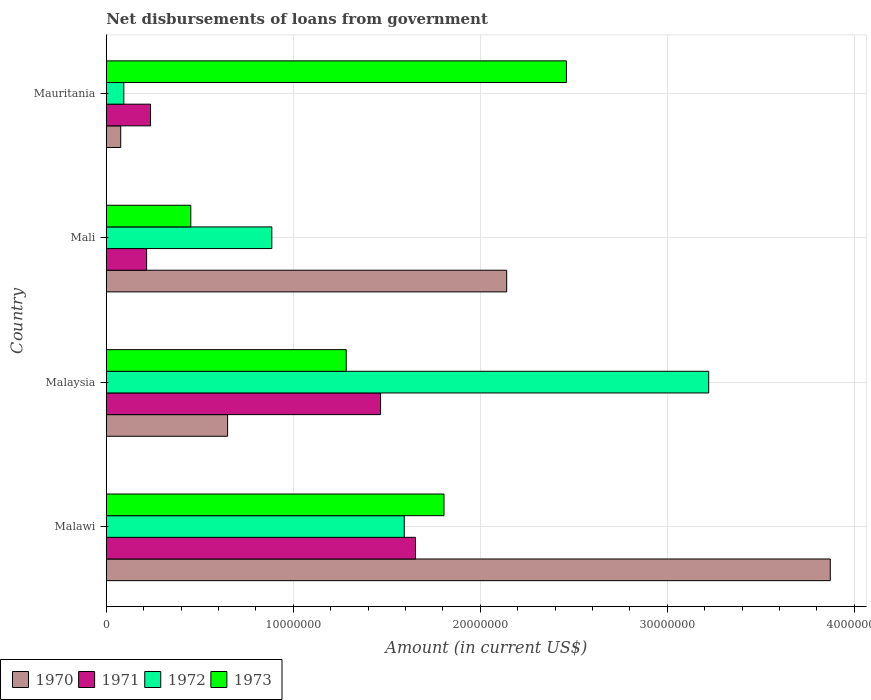How many different coloured bars are there?
Your response must be concise. 4. Are the number of bars per tick equal to the number of legend labels?
Your response must be concise. Yes. How many bars are there on the 4th tick from the top?
Keep it short and to the point. 4. What is the label of the 1st group of bars from the top?
Offer a terse response. Mauritania. What is the amount of loan disbursed from government in 1971 in Mali?
Keep it short and to the point. 2.16e+06. Across all countries, what is the maximum amount of loan disbursed from government in 1972?
Offer a terse response. 3.22e+07. Across all countries, what is the minimum amount of loan disbursed from government in 1972?
Ensure brevity in your answer.  9.39e+05. In which country was the amount of loan disbursed from government in 1971 maximum?
Your answer should be very brief. Malawi. In which country was the amount of loan disbursed from government in 1972 minimum?
Provide a succinct answer. Mauritania. What is the total amount of loan disbursed from government in 1972 in the graph?
Your answer should be compact. 5.79e+07. What is the difference between the amount of loan disbursed from government in 1971 in Malawi and that in Malaysia?
Your response must be concise. 1.87e+06. What is the difference between the amount of loan disbursed from government in 1970 in Malaysia and the amount of loan disbursed from government in 1972 in Mauritania?
Ensure brevity in your answer.  5.55e+06. What is the average amount of loan disbursed from government in 1973 per country?
Ensure brevity in your answer.  1.50e+07. What is the difference between the amount of loan disbursed from government in 1972 and amount of loan disbursed from government in 1971 in Mali?
Your answer should be compact. 6.70e+06. What is the ratio of the amount of loan disbursed from government in 1971 in Malawi to that in Mali?
Make the answer very short. 7.66. What is the difference between the highest and the second highest amount of loan disbursed from government in 1972?
Give a very brief answer. 1.63e+07. What is the difference between the highest and the lowest amount of loan disbursed from government in 1972?
Offer a very short reply. 3.13e+07. Is the sum of the amount of loan disbursed from government in 1973 in Malawi and Mauritania greater than the maximum amount of loan disbursed from government in 1971 across all countries?
Provide a succinct answer. Yes. What does the 2nd bar from the top in Mauritania represents?
Provide a short and direct response. 1972. Are all the bars in the graph horizontal?
Offer a very short reply. Yes. Are the values on the major ticks of X-axis written in scientific E-notation?
Give a very brief answer. No. How are the legend labels stacked?
Give a very brief answer. Horizontal. What is the title of the graph?
Give a very brief answer. Net disbursements of loans from government. Does "2006" appear as one of the legend labels in the graph?
Your answer should be compact. No. What is the label or title of the Y-axis?
Your answer should be compact. Country. What is the Amount (in current US$) in 1970 in Malawi?
Your response must be concise. 3.87e+07. What is the Amount (in current US$) of 1971 in Malawi?
Keep it short and to the point. 1.65e+07. What is the Amount (in current US$) of 1972 in Malawi?
Make the answer very short. 1.59e+07. What is the Amount (in current US$) of 1973 in Malawi?
Your answer should be compact. 1.81e+07. What is the Amount (in current US$) of 1970 in Malaysia?
Make the answer very short. 6.49e+06. What is the Amount (in current US$) of 1971 in Malaysia?
Offer a terse response. 1.47e+07. What is the Amount (in current US$) of 1972 in Malaysia?
Your answer should be compact. 3.22e+07. What is the Amount (in current US$) in 1973 in Malaysia?
Provide a succinct answer. 1.28e+07. What is the Amount (in current US$) of 1970 in Mali?
Your response must be concise. 2.14e+07. What is the Amount (in current US$) of 1971 in Mali?
Your answer should be compact. 2.16e+06. What is the Amount (in current US$) in 1972 in Mali?
Your answer should be very brief. 8.85e+06. What is the Amount (in current US$) of 1973 in Mali?
Your response must be concise. 4.52e+06. What is the Amount (in current US$) of 1970 in Mauritania?
Provide a short and direct response. 7.74e+05. What is the Amount (in current US$) in 1971 in Mauritania?
Provide a short and direct response. 2.37e+06. What is the Amount (in current US$) in 1972 in Mauritania?
Your response must be concise. 9.39e+05. What is the Amount (in current US$) in 1973 in Mauritania?
Provide a succinct answer. 2.46e+07. Across all countries, what is the maximum Amount (in current US$) of 1970?
Offer a very short reply. 3.87e+07. Across all countries, what is the maximum Amount (in current US$) of 1971?
Give a very brief answer. 1.65e+07. Across all countries, what is the maximum Amount (in current US$) in 1972?
Your answer should be compact. 3.22e+07. Across all countries, what is the maximum Amount (in current US$) in 1973?
Make the answer very short. 2.46e+07. Across all countries, what is the minimum Amount (in current US$) in 1970?
Your answer should be compact. 7.74e+05. Across all countries, what is the minimum Amount (in current US$) of 1971?
Offer a terse response. 2.16e+06. Across all countries, what is the minimum Amount (in current US$) of 1972?
Offer a very short reply. 9.39e+05. Across all countries, what is the minimum Amount (in current US$) in 1973?
Offer a terse response. 4.52e+06. What is the total Amount (in current US$) in 1970 in the graph?
Provide a short and direct response. 6.74e+07. What is the total Amount (in current US$) of 1971 in the graph?
Your answer should be very brief. 3.57e+07. What is the total Amount (in current US$) in 1972 in the graph?
Offer a terse response. 5.79e+07. What is the total Amount (in current US$) of 1973 in the graph?
Make the answer very short. 6.00e+07. What is the difference between the Amount (in current US$) of 1970 in Malawi and that in Malaysia?
Your answer should be very brief. 3.22e+07. What is the difference between the Amount (in current US$) in 1971 in Malawi and that in Malaysia?
Offer a terse response. 1.87e+06. What is the difference between the Amount (in current US$) in 1972 in Malawi and that in Malaysia?
Give a very brief answer. -1.63e+07. What is the difference between the Amount (in current US$) in 1973 in Malawi and that in Malaysia?
Offer a terse response. 5.23e+06. What is the difference between the Amount (in current US$) in 1970 in Malawi and that in Mali?
Your answer should be compact. 1.73e+07. What is the difference between the Amount (in current US$) in 1971 in Malawi and that in Mali?
Offer a terse response. 1.44e+07. What is the difference between the Amount (in current US$) in 1972 in Malawi and that in Mali?
Your answer should be compact. 7.08e+06. What is the difference between the Amount (in current US$) in 1973 in Malawi and that in Mali?
Your answer should be very brief. 1.35e+07. What is the difference between the Amount (in current US$) of 1970 in Malawi and that in Mauritania?
Your answer should be compact. 3.79e+07. What is the difference between the Amount (in current US$) of 1971 in Malawi and that in Mauritania?
Offer a terse response. 1.42e+07. What is the difference between the Amount (in current US$) in 1972 in Malawi and that in Mauritania?
Give a very brief answer. 1.50e+07. What is the difference between the Amount (in current US$) of 1973 in Malawi and that in Mauritania?
Your answer should be very brief. -6.55e+06. What is the difference between the Amount (in current US$) of 1970 in Malaysia and that in Mali?
Ensure brevity in your answer.  -1.49e+07. What is the difference between the Amount (in current US$) in 1971 in Malaysia and that in Mali?
Provide a short and direct response. 1.25e+07. What is the difference between the Amount (in current US$) in 1972 in Malaysia and that in Mali?
Your answer should be very brief. 2.34e+07. What is the difference between the Amount (in current US$) in 1973 in Malaysia and that in Mali?
Provide a succinct answer. 8.31e+06. What is the difference between the Amount (in current US$) in 1970 in Malaysia and that in Mauritania?
Your answer should be very brief. 5.72e+06. What is the difference between the Amount (in current US$) in 1971 in Malaysia and that in Mauritania?
Make the answer very short. 1.23e+07. What is the difference between the Amount (in current US$) of 1972 in Malaysia and that in Mauritania?
Provide a short and direct response. 3.13e+07. What is the difference between the Amount (in current US$) in 1973 in Malaysia and that in Mauritania?
Offer a terse response. -1.18e+07. What is the difference between the Amount (in current US$) in 1970 in Mali and that in Mauritania?
Your answer should be very brief. 2.06e+07. What is the difference between the Amount (in current US$) of 1971 in Mali and that in Mauritania?
Your answer should be very brief. -2.09e+05. What is the difference between the Amount (in current US$) in 1972 in Mali and that in Mauritania?
Your answer should be very brief. 7.92e+06. What is the difference between the Amount (in current US$) in 1973 in Mali and that in Mauritania?
Ensure brevity in your answer.  -2.01e+07. What is the difference between the Amount (in current US$) of 1970 in Malawi and the Amount (in current US$) of 1971 in Malaysia?
Your answer should be very brief. 2.40e+07. What is the difference between the Amount (in current US$) in 1970 in Malawi and the Amount (in current US$) in 1972 in Malaysia?
Your answer should be very brief. 6.50e+06. What is the difference between the Amount (in current US$) in 1970 in Malawi and the Amount (in current US$) in 1973 in Malaysia?
Offer a very short reply. 2.59e+07. What is the difference between the Amount (in current US$) in 1971 in Malawi and the Amount (in current US$) in 1972 in Malaysia?
Offer a terse response. -1.57e+07. What is the difference between the Amount (in current US$) of 1971 in Malawi and the Amount (in current US$) of 1973 in Malaysia?
Your response must be concise. 3.71e+06. What is the difference between the Amount (in current US$) in 1972 in Malawi and the Amount (in current US$) in 1973 in Malaysia?
Your answer should be compact. 3.10e+06. What is the difference between the Amount (in current US$) of 1970 in Malawi and the Amount (in current US$) of 1971 in Mali?
Keep it short and to the point. 3.66e+07. What is the difference between the Amount (in current US$) in 1970 in Malawi and the Amount (in current US$) in 1972 in Mali?
Offer a very short reply. 2.99e+07. What is the difference between the Amount (in current US$) in 1970 in Malawi and the Amount (in current US$) in 1973 in Mali?
Offer a very short reply. 3.42e+07. What is the difference between the Amount (in current US$) of 1971 in Malawi and the Amount (in current US$) of 1972 in Mali?
Provide a short and direct response. 7.68e+06. What is the difference between the Amount (in current US$) in 1971 in Malawi and the Amount (in current US$) in 1973 in Mali?
Your answer should be compact. 1.20e+07. What is the difference between the Amount (in current US$) in 1972 in Malawi and the Amount (in current US$) in 1973 in Mali?
Offer a very short reply. 1.14e+07. What is the difference between the Amount (in current US$) of 1970 in Malawi and the Amount (in current US$) of 1971 in Mauritania?
Give a very brief answer. 3.63e+07. What is the difference between the Amount (in current US$) of 1970 in Malawi and the Amount (in current US$) of 1972 in Mauritania?
Give a very brief answer. 3.78e+07. What is the difference between the Amount (in current US$) of 1970 in Malawi and the Amount (in current US$) of 1973 in Mauritania?
Your answer should be compact. 1.41e+07. What is the difference between the Amount (in current US$) of 1971 in Malawi and the Amount (in current US$) of 1972 in Mauritania?
Give a very brief answer. 1.56e+07. What is the difference between the Amount (in current US$) of 1971 in Malawi and the Amount (in current US$) of 1973 in Mauritania?
Ensure brevity in your answer.  -8.07e+06. What is the difference between the Amount (in current US$) of 1972 in Malawi and the Amount (in current US$) of 1973 in Mauritania?
Ensure brevity in your answer.  -8.67e+06. What is the difference between the Amount (in current US$) in 1970 in Malaysia and the Amount (in current US$) in 1971 in Mali?
Your answer should be compact. 4.33e+06. What is the difference between the Amount (in current US$) in 1970 in Malaysia and the Amount (in current US$) in 1972 in Mali?
Your response must be concise. -2.36e+06. What is the difference between the Amount (in current US$) of 1970 in Malaysia and the Amount (in current US$) of 1973 in Mali?
Make the answer very short. 1.97e+06. What is the difference between the Amount (in current US$) of 1971 in Malaysia and the Amount (in current US$) of 1972 in Mali?
Make the answer very short. 5.82e+06. What is the difference between the Amount (in current US$) of 1971 in Malaysia and the Amount (in current US$) of 1973 in Mali?
Make the answer very short. 1.01e+07. What is the difference between the Amount (in current US$) of 1972 in Malaysia and the Amount (in current US$) of 1973 in Mali?
Your answer should be compact. 2.77e+07. What is the difference between the Amount (in current US$) of 1970 in Malaysia and the Amount (in current US$) of 1971 in Mauritania?
Make the answer very short. 4.12e+06. What is the difference between the Amount (in current US$) in 1970 in Malaysia and the Amount (in current US$) in 1972 in Mauritania?
Provide a short and direct response. 5.55e+06. What is the difference between the Amount (in current US$) in 1970 in Malaysia and the Amount (in current US$) in 1973 in Mauritania?
Give a very brief answer. -1.81e+07. What is the difference between the Amount (in current US$) in 1971 in Malaysia and the Amount (in current US$) in 1972 in Mauritania?
Offer a very short reply. 1.37e+07. What is the difference between the Amount (in current US$) in 1971 in Malaysia and the Amount (in current US$) in 1973 in Mauritania?
Offer a very short reply. -9.94e+06. What is the difference between the Amount (in current US$) in 1972 in Malaysia and the Amount (in current US$) in 1973 in Mauritania?
Ensure brevity in your answer.  7.61e+06. What is the difference between the Amount (in current US$) of 1970 in Mali and the Amount (in current US$) of 1971 in Mauritania?
Make the answer very short. 1.90e+07. What is the difference between the Amount (in current US$) in 1970 in Mali and the Amount (in current US$) in 1972 in Mauritania?
Provide a short and direct response. 2.05e+07. What is the difference between the Amount (in current US$) in 1970 in Mali and the Amount (in current US$) in 1973 in Mauritania?
Provide a succinct answer. -3.20e+06. What is the difference between the Amount (in current US$) in 1971 in Mali and the Amount (in current US$) in 1972 in Mauritania?
Offer a terse response. 1.22e+06. What is the difference between the Amount (in current US$) of 1971 in Mali and the Amount (in current US$) of 1973 in Mauritania?
Provide a succinct answer. -2.24e+07. What is the difference between the Amount (in current US$) in 1972 in Mali and the Amount (in current US$) in 1973 in Mauritania?
Your response must be concise. -1.58e+07. What is the average Amount (in current US$) of 1970 per country?
Your answer should be very brief. 1.68e+07. What is the average Amount (in current US$) in 1971 per country?
Provide a short and direct response. 8.93e+06. What is the average Amount (in current US$) of 1972 per country?
Ensure brevity in your answer.  1.45e+07. What is the average Amount (in current US$) of 1973 per country?
Make the answer very short. 1.50e+07. What is the difference between the Amount (in current US$) of 1970 and Amount (in current US$) of 1971 in Malawi?
Offer a very short reply. 2.22e+07. What is the difference between the Amount (in current US$) of 1970 and Amount (in current US$) of 1972 in Malawi?
Offer a very short reply. 2.28e+07. What is the difference between the Amount (in current US$) in 1970 and Amount (in current US$) in 1973 in Malawi?
Provide a short and direct response. 2.07e+07. What is the difference between the Amount (in current US$) of 1971 and Amount (in current US$) of 1972 in Malawi?
Offer a very short reply. 6.02e+05. What is the difference between the Amount (in current US$) of 1971 and Amount (in current US$) of 1973 in Malawi?
Give a very brief answer. -1.52e+06. What is the difference between the Amount (in current US$) of 1972 and Amount (in current US$) of 1973 in Malawi?
Keep it short and to the point. -2.12e+06. What is the difference between the Amount (in current US$) of 1970 and Amount (in current US$) of 1971 in Malaysia?
Offer a terse response. -8.18e+06. What is the difference between the Amount (in current US$) in 1970 and Amount (in current US$) in 1972 in Malaysia?
Provide a short and direct response. -2.57e+07. What is the difference between the Amount (in current US$) of 1970 and Amount (in current US$) of 1973 in Malaysia?
Your answer should be compact. -6.34e+06. What is the difference between the Amount (in current US$) in 1971 and Amount (in current US$) in 1972 in Malaysia?
Your answer should be compact. -1.75e+07. What is the difference between the Amount (in current US$) of 1971 and Amount (in current US$) of 1973 in Malaysia?
Keep it short and to the point. 1.84e+06. What is the difference between the Amount (in current US$) of 1972 and Amount (in current US$) of 1973 in Malaysia?
Provide a succinct answer. 1.94e+07. What is the difference between the Amount (in current US$) of 1970 and Amount (in current US$) of 1971 in Mali?
Provide a succinct answer. 1.93e+07. What is the difference between the Amount (in current US$) of 1970 and Amount (in current US$) of 1972 in Mali?
Make the answer very short. 1.26e+07. What is the difference between the Amount (in current US$) in 1970 and Amount (in current US$) in 1973 in Mali?
Make the answer very short. 1.69e+07. What is the difference between the Amount (in current US$) in 1971 and Amount (in current US$) in 1972 in Mali?
Provide a short and direct response. -6.70e+06. What is the difference between the Amount (in current US$) in 1971 and Amount (in current US$) in 1973 in Mali?
Provide a succinct answer. -2.36e+06. What is the difference between the Amount (in current US$) of 1972 and Amount (in current US$) of 1973 in Mali?
Your answer should be compact. 4.33e+06. What is the difference between the Amount (in current US$) in 1970 and Amount (in current US$) in 1971 in Mauritania?
Ensure brevity in your answer.  -1.59e+06. What is the difference between the Amount (in current US$) in 1970 and Amount (in current US$) in 1972 in Mauritania?
Ensure brevity in your answer.  -1.65e+05. What is the difference between the Amount (in current US$) of 1970 and Amount (in current US$) of 1973 in Mauritania?
Provide a succinct answer. -2.38e+07. What is the difference between the Amount (in current US$) of 1971 and Amount (in current US$) of 1972 in Mauritania?
Your answer should be compact. 1.43e+06. What is the difference between the Amount (in current US$) in 1971 and Amount (in current US$) in 1973 in Mauritania?
Give a very brief answer. -2.22e+07. What is the difference between the Amount (in current US$) of 1972 and Amount (in current US$) of 1973 in Mauritania?
Your response must be concise. -2.37e+07. What is the ratio of the Amount (in current US$) of 1970 in Malawi to that in Malaysia?
Keep it short and to the point. 5.97. What is the ratio of the Amount (in current US$) of 1971 in Malawi to that in Malaysia?
Offer a very short reply. 1.13. What is the ratio of the Amount (in current US$) of 1972 in Malawi to that in Malaysia?
Your answer should be very brief. 0.49. What is the ratio of the Amount (in current US$) of 1973 in Malawi to that in Malaysia?
Offer a terse response. 1.41. What is the ratio of the Amount (in current US$) of 1970 in Malawi to that in Mali?
Provide a succinct answer. 1.81. What is the ratio of the Amount (in current US$) of 1971 in Malawi to that in Mali?
Your answer should be compact. 7.66. What is the ratio of the Amount (in current US$) of 1972 in Malawi to that in Mali?
Offer a very short reply. 1.8. What is the ratio of the Amount (in current US$) in 1973 in Malawi to that in Mali?
Your answer should be very brief. 3.99. What is the ratio of the Amount (in current US$) in 1970 in Malawi to that in Mauritania?
Your response must be concise. 50.02. What is the ratio of the Amount (in current US$) of 1971 in Malawi to that in Mauritania?
Provide a succinct answer. 6.98. What is the ratio of the Amount (in current US$) in 1972 in Malawi to that in Mauritania?
Make the answer very short. 16.97. What is the ratio of the Amount (in current US$) of 1973 in Malawi to that in Mauritania?
Offer a terse response. 0.73. What is the ratio of the Amount (in current US$) of 1970 in Malaysia to that in Mali?
Your answer should be compact. 0.3. What is the ratio of the Amount (in current US$) in 1971 in Malaysia to that in Mali?
Your answer should be very brief. 6.79. What is the ratio of the Amount (in current US$) of 1972 in Malaysia to that in Mali?
Your answer should be very brief. 3.64. What is the ratio of the Amount (in current US$) of 1973 in Malaysia to that in Mali?
Offer a terse response. 2.84. What is the ratio of the Amount (in current US$) of 1970 in Malaysia to that in Mauritania?
Your answer should be very brief. 8.38. What is the ratio of the Amount (in current US$) of 1971 in Malaysia to that in Mauritania?
Your answer should be very brief. 6.19. What is the ratio of the Amount (in current US$) of 1972 in Malaysia to that in Mauritania?
Offer a very short reply. 34.31. What is the ratio of the Amount (in current US$) of 1973 in Malaysia to that in Mauritania?
Keep it short and to the point. 0.52. What is the ratio of the Amount (in current US$) of 1970 in Mali to that in Mauritania?
Keep it short and to the point. 27.67. What is the ratio of the Amount (in current US$) of 1971 in Mali to that in Mauritania?
Make the answer very short. 0.91. What is the ratio of the Amount (in current US$) in 1972 in Mali to that in Mauritania?
Your answer should be compact. 9.43. What is the ratio of the Amount (in current US$) of 1973 in Mali to that in Mauritania?
Your answer should be compact. 0.18. What is the difference between the highest and the second highest Amount (in current US$) in 1970?
Give a very brief answer. 1.73e+07. What is the difference between the highest and the second highest Amount (in current US$) in 1971?
Offer a terse response. 1.87e+06. What is the difference between the highest and the second highest Amount (in current US$) in 1972?
Provide a succinct answer. 1.63e+07. What is the difference between the highest and the second highest Amount (in current US$) of 1973?
Your answer should be compact. 6.55e+06. What is the difference between the highest and the lowest Amount (in current US$) of 1970?
Ensure brevity in your answer.  3.79e+07. What is the difference between the highest and the lowest Amount (in current US$) in 1971?
Offer a very short reply. 1.44e+07. What is the difference between the highest and the lowest Amount (in current US$) of 1972?
Ensure brevity in your answer.  3.13e+07. What is the difference between the highest and the lowest Amount (in current US$) of 1973?
Ensure brevity in your answer.  2.01e+07. 